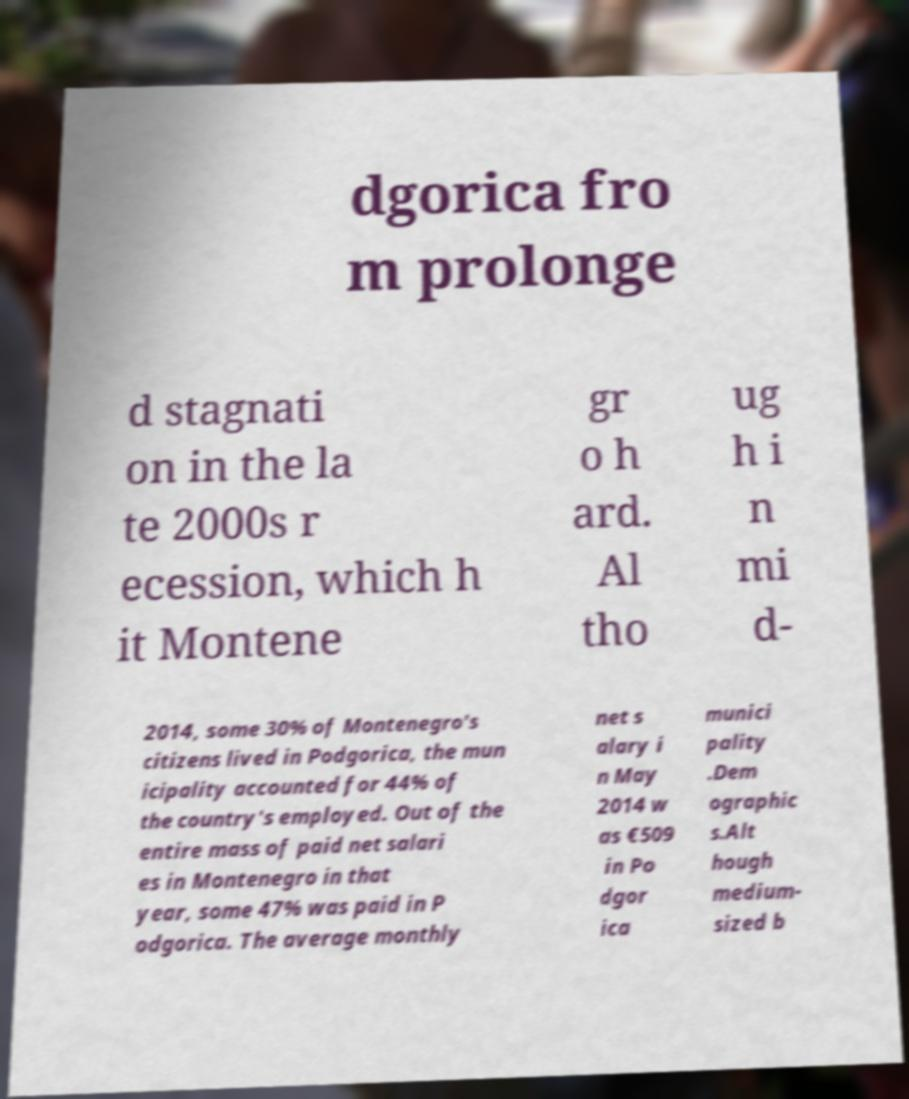Could you assist in decoding the text presented in this image and type it out clearly? dgorica fro m prolonge d stagnati on in the la te 2000s r ecession, which h it Montene gr o h ard. Al tho ug h i n mi d- 2014, some 30% of Montenegro's citizens lived in Podgorica, the mun icipality accounted for 44% of the country's employed. Out of the entire mass of paid net salari es in Montenegro in that year, some 47% was paid in P odgorica. The average monthly net s alary i n May 2014 w as €509 in Po dgor ica munici pality .Dem ographic s.Alt hough medium- sized b 